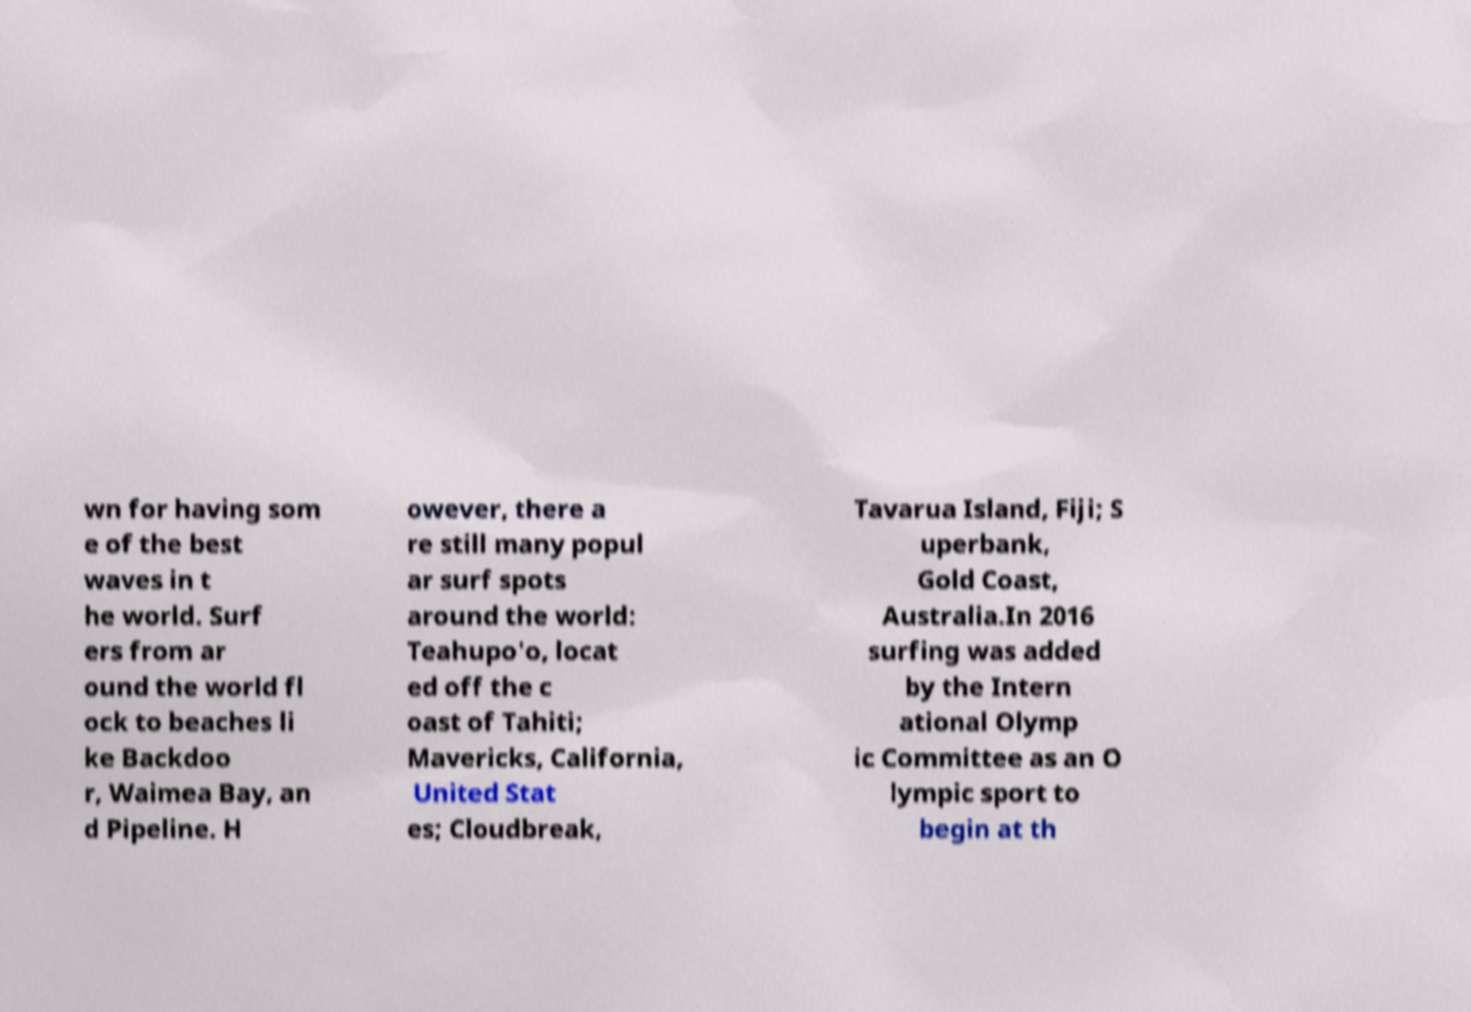Could you assist in decoding the text presented in this image and type it out clearly? wn for having som e of the best waves in t he world. Surf ers from ar ound the world fl ock to beaches li ke Backdoo r, Waimea Bay, an d Pipeline. H owever, there a re still many popul ar surf spots around the world: Teahupo'o, locat ed off the c oast of Tahiti; Mavericks, California, United Stat es; Cloudbreak, Tavarua Island, Fiji; S uperbank, Gold Coast, Australia.In 2016 surfing was added by the Intern ational Olymp ic Committee as an O lympic sport to begin at th 